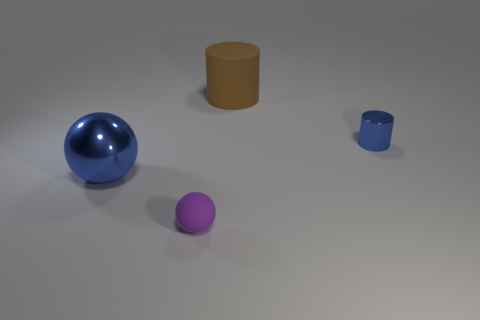Are there more matte cylinders on the left side of the small matte sphere than purple things that are behind the large sphere?
Offer a terse response. No. There is a blue thing that is right of the purple ball; how many tiny purple matte balls are behind it?
Keep it short and to the point. 0. Is there a metallic object of the same color as the metallic cylinder?
Provide a succinct answer. Yes. Is the size of the metal ball the same as the brown object?
Your answer should be compact. Yes. Is the shiny cylinder the same color as the large sphere?
Provide a short and direct response. Yes. What is the material of the large thing right of the tiny thing that is in front of the big metallic sphere?
Provide a succinct answer. Rubber. There is a large brown object that is the same shape as the tiny blue metallic object; what is it made of?
Your response must be concise. Rubber. Does the matte thing in front of the rubber cylinder have the same size as the tiny metallic thing?
Give a very brief answer. Yes. What number of matte things are either tiny brown cubes or large balls?
Your answer should be compact. 0. What material is the object that is both left of the tiny blue metal thing and to the right of the tiny purple ball?
Provide a succinct answer. Rubber. 